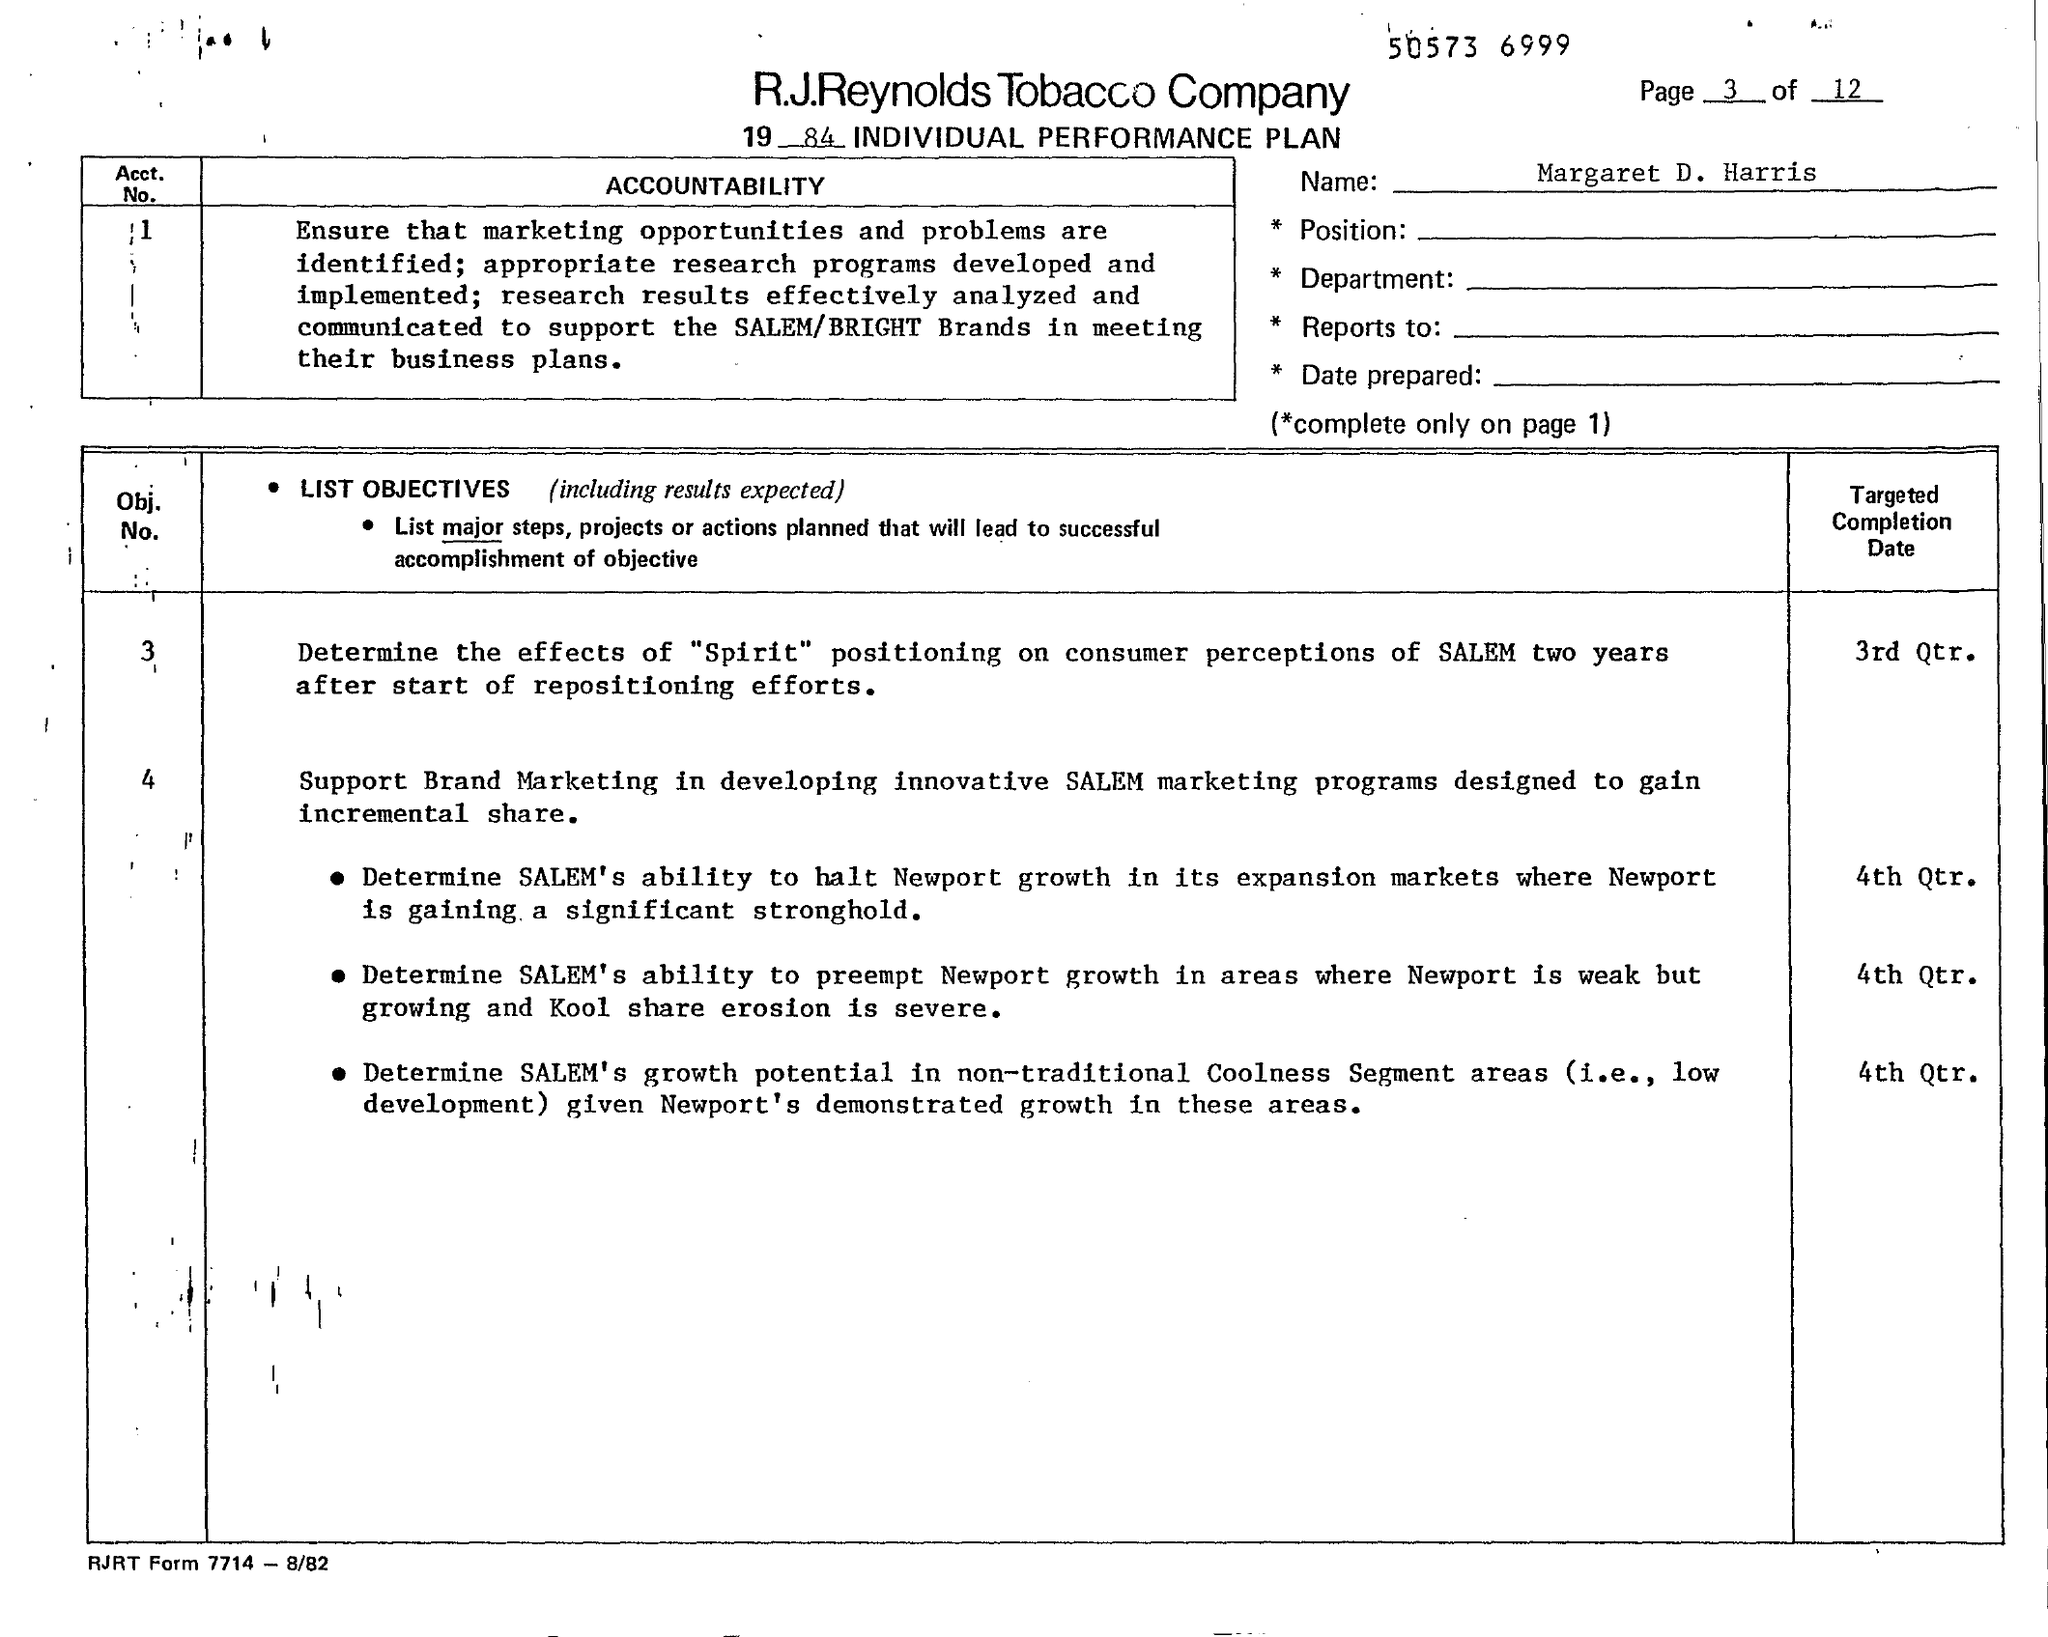Outline some significant characteristics in this image. The name is Margaret D. Harris. 